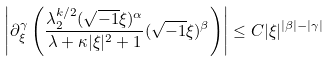<formula> <loc_0><loc_0><loc_500><loc_500>\left | \partial ^ { \gamma } _ { \xi } \left ( \frac { \lambda ^ { k / 2 } _ { 2 } ( \sqrt { - 1 } \xi ) ^ { \alpha } } { \lambda + \kappa | \xi | ^ { 2 } + 1 } ( \sqrt { - 1 } \xi ) ^ { \beta } \right ) \right | \leq C | \xi | ^ { | \beta | - | \gamma | }</formula> 